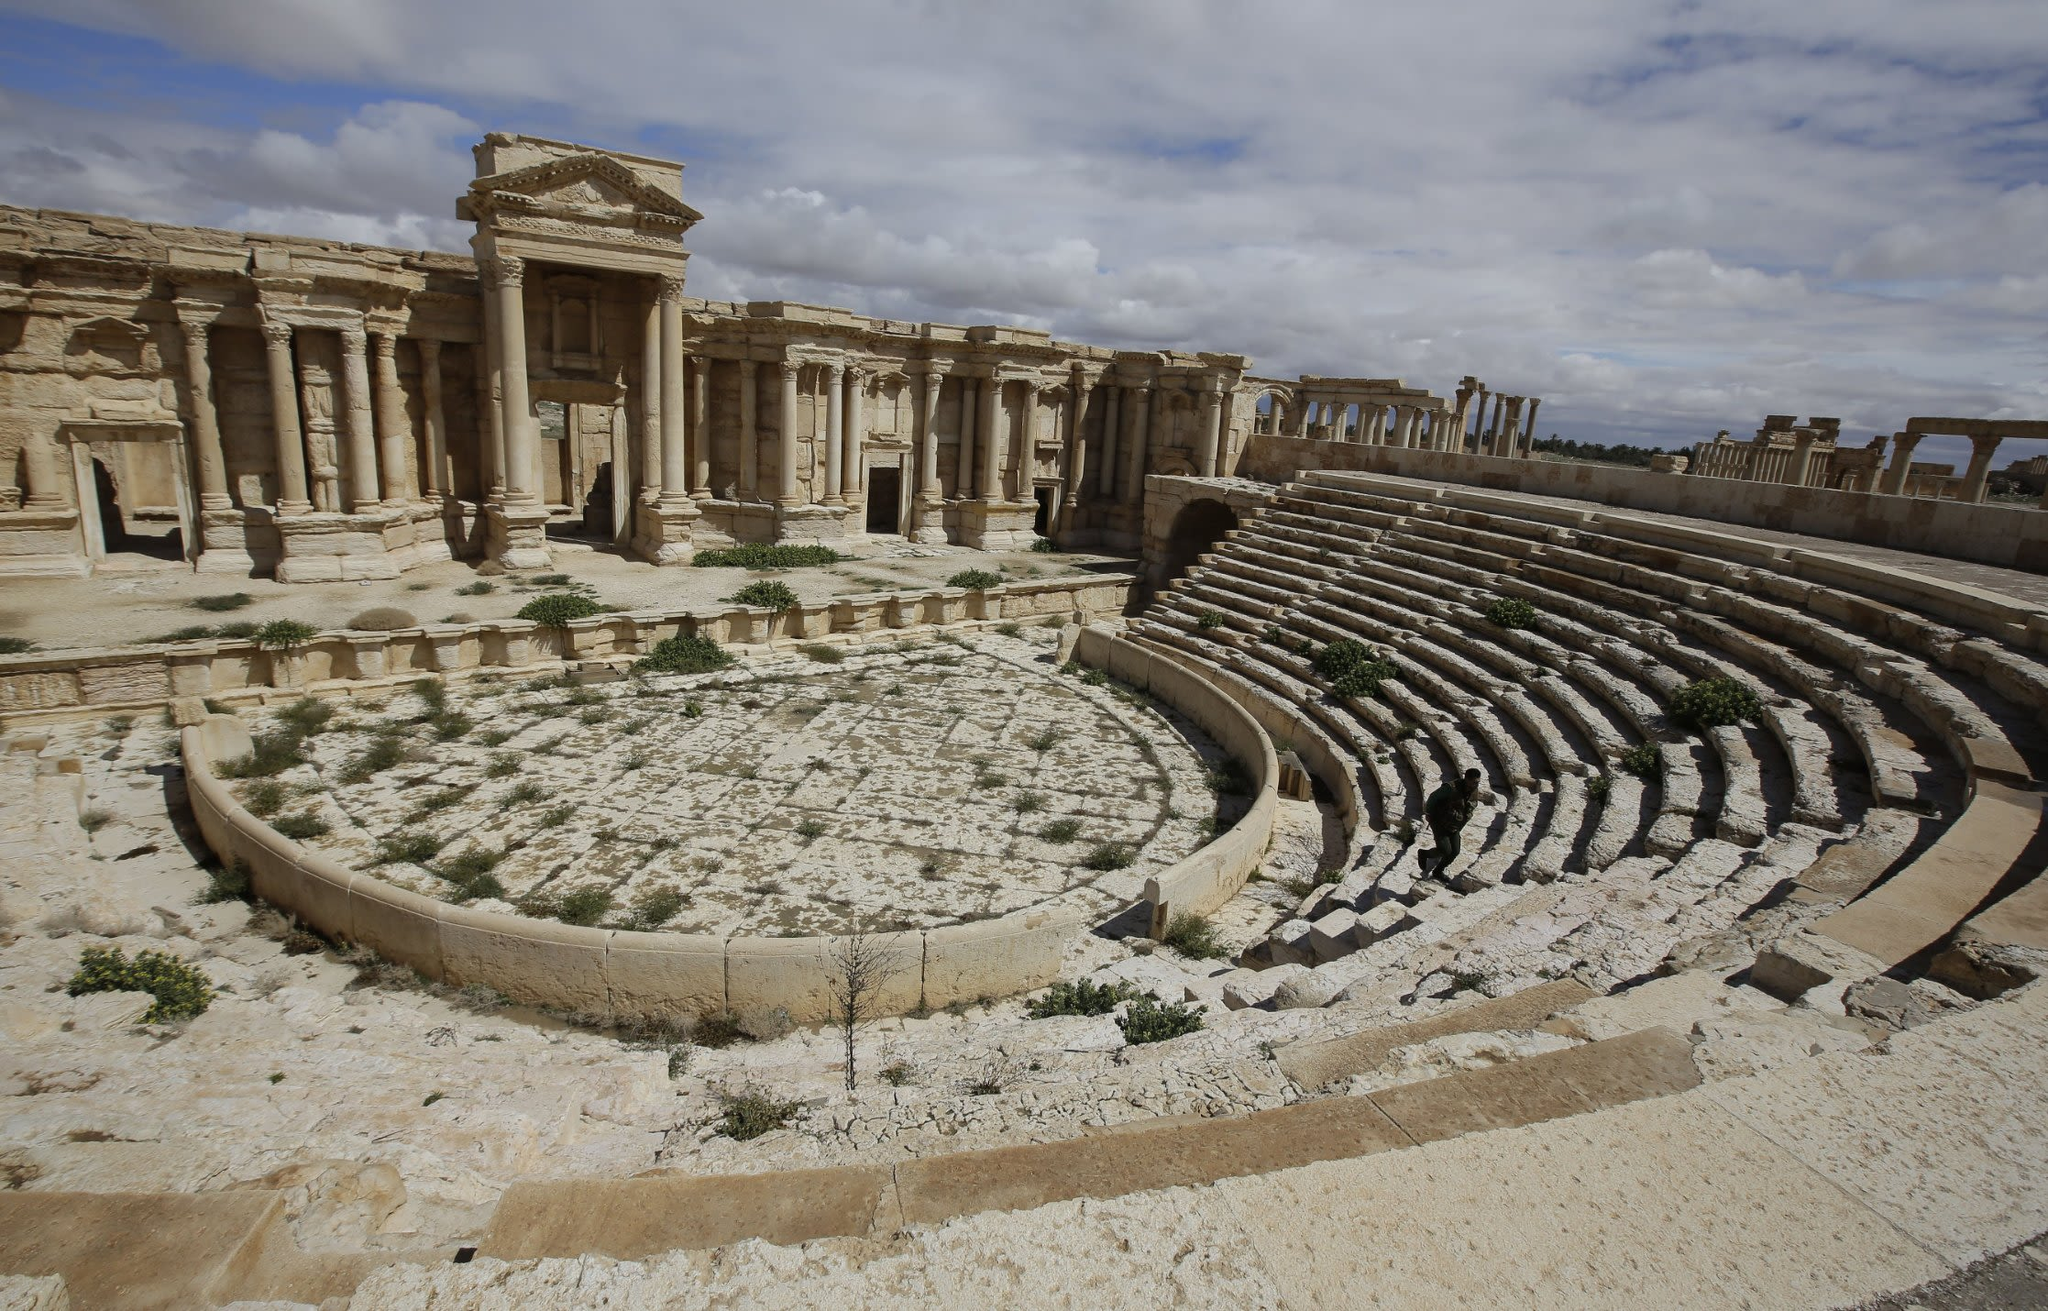If this theater could tell a story, what tales might it share? If this theater could tell its story, it would recount the myriad of performances that graced its stage—from tragic plays of human folly and divine intervention to comedic farces that drew peals of laughter from the gathering crowds. It would share the stories of grand festivals and ceremonies, and perhaps even political debates and public announcements made to assembled citizens. The theater would speak of its survival through the centuries, witnessing the rise and fall of empires, standing resilient through the passing of time. Each stone and pillar would whisper memories of the artisans who built it, the actors who brought it to life, and the countless audiences who sat in its seats, rejoicing or grieving with the unfolding dramas before them. 